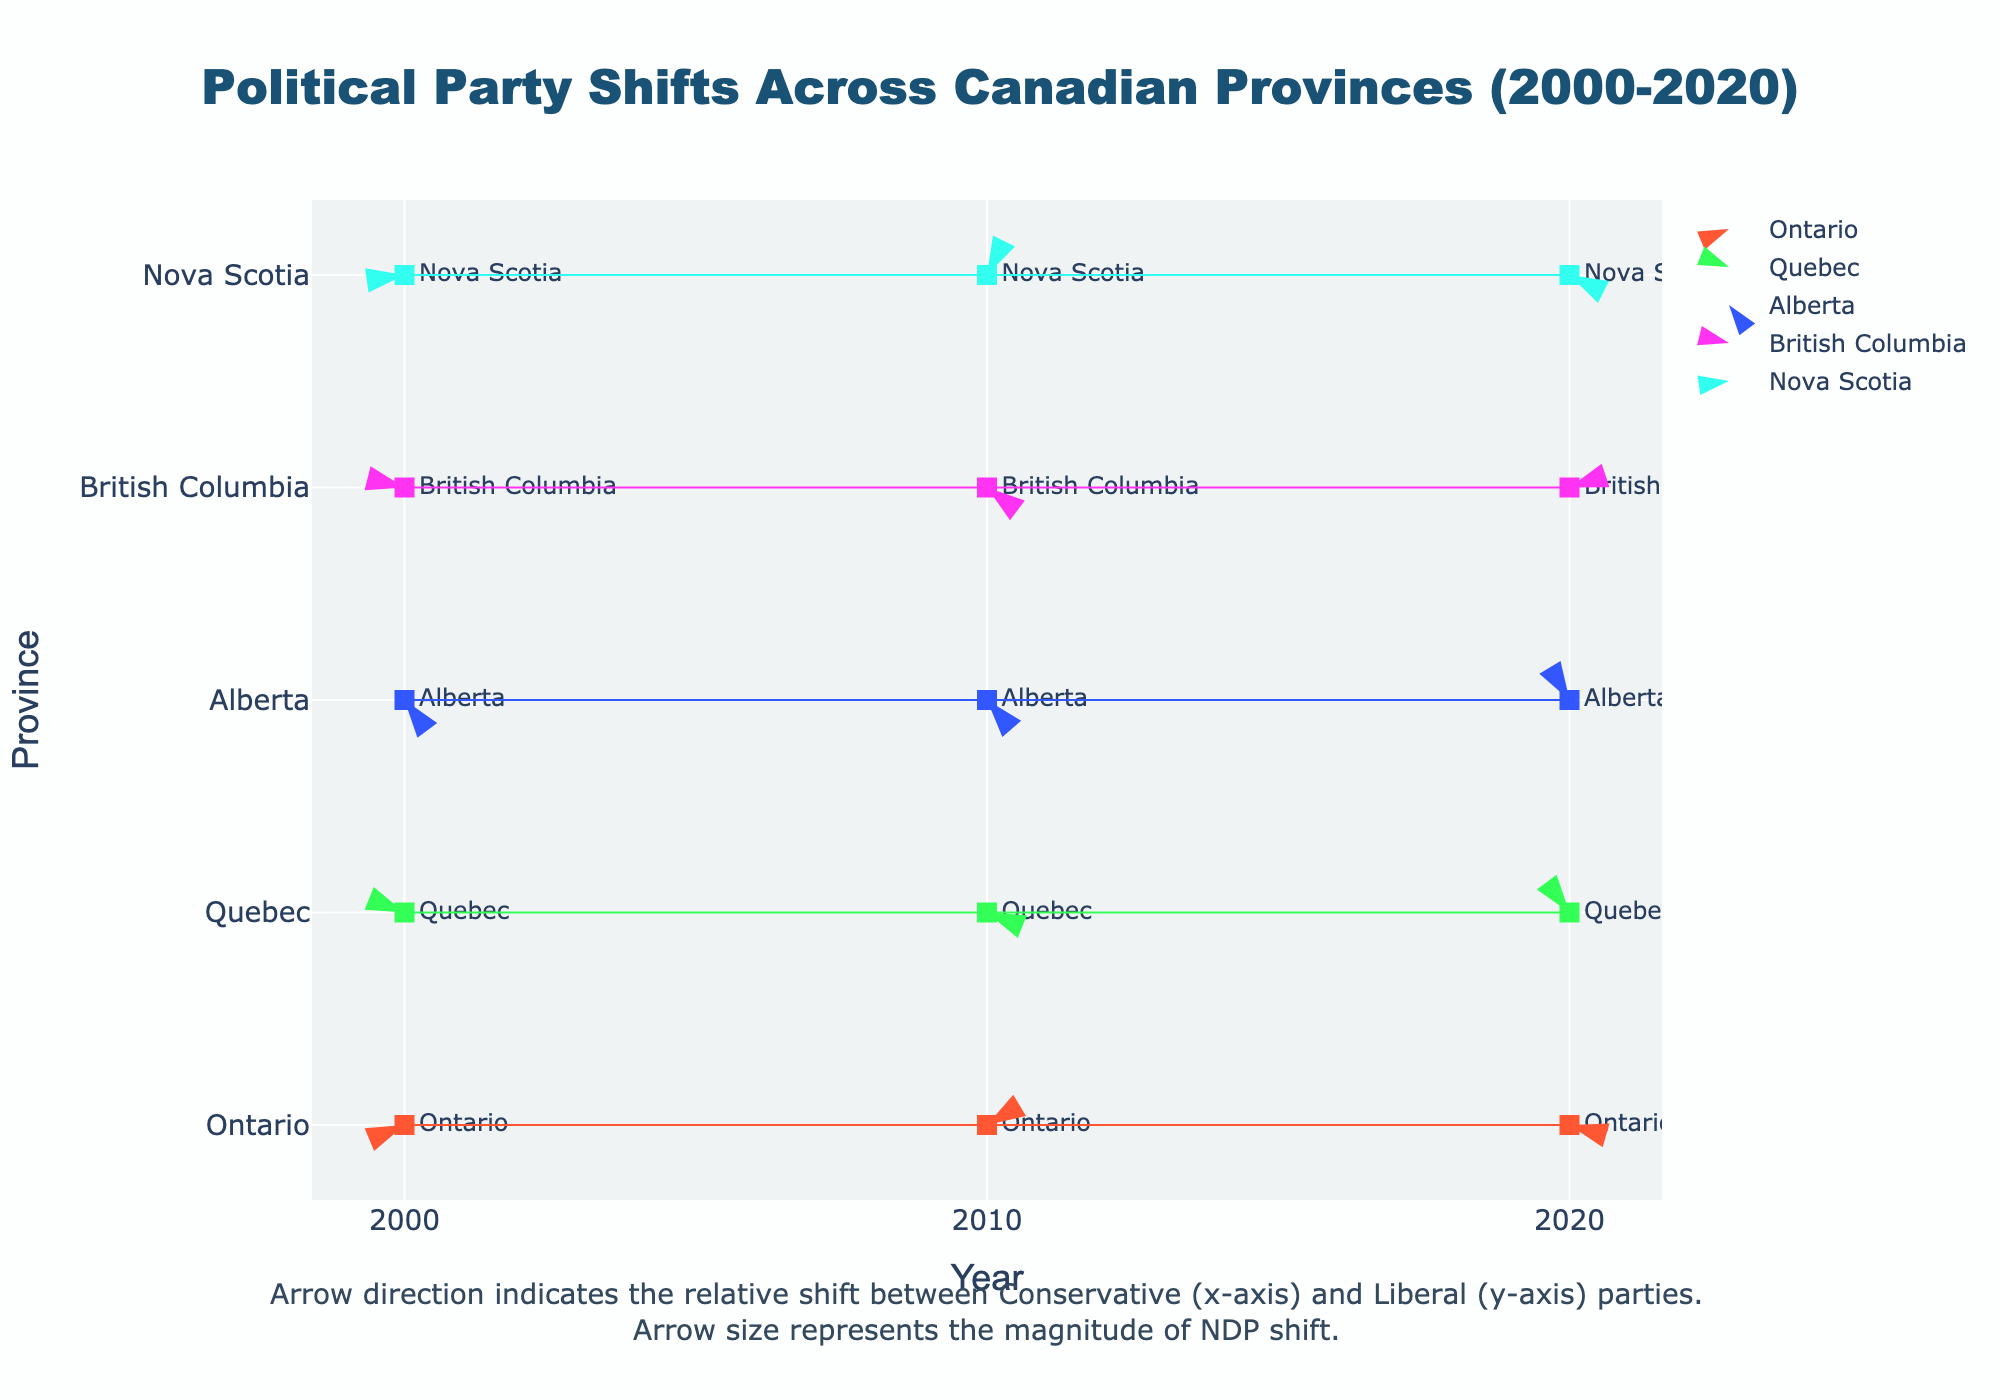What is the title of the figure? The title of the figure is located at the top and it reads, "Political Party Shifts Across Canadian Provinces (2000-2020)."
Answer: Political Party Shifts Across Canadian Provinces (2000-2020) Which province shows the largest conservative shift in 2000? The quiver plot indicates direction and magnitude of shifts; to determine the largest Conservative shift, look for the province with the longest arrow pointing towards the Conservative direction. In 2000, Alberta shows the largest positive conservative shift.
Answer: Alberta How did the political landscape in Quebec change for the Conservative and Liberal parties between 2000 and 2020? Look at the arrows representing Quebec in 2000 and 2020. In 2000, the arrow for Quebec shows a negative shift for Conservatives and a large positive shift for Liberals. In 2020, the arrow shows a negative shift for Conservatives and a positive shift for Liberals but less significantly than in 2000.
Answer: Conservative shift decreased more negatively and Liberal shift decreased Which province had a positive shift for both Conservative and Liberal parties at any point in time? Examine the arrows' directions across all provinces for any point in time. In 2010, Ontario had a small negative shift in both Conservative and Liberal parties.
Answer: None Which year shows the greatest overall shift for the province of British Columbia? Look at the arrows for British Columbia in 2000, 2010, and 2020 and compare the length and direction of the arrows. The longest arrow, representing the greatest overall magnitude of shift, occurred in 2000.
Answer: 2000 Between 2000 and 2020, which province experienced the most significant positive shift in NDP? Examine the length of the arrows in the direction that indicates NDP positive shift. Nova Scotia in 2010 shows the largest positive shift for NDP.
Answer: Nova Scotia How does the shift in Alberta's political landscape in 2020 compare to that in 2010? Look at the direction and length of the arrows for Alberta in 2010 and 2020. In 2010, the arrow points positively for Conservative but negatively for Liberal and NDP. In 2020, the shift is negative for Conservative, positive for Liberal, and slightly positive for NDP. Alberta shows a significant change from a strong Conservative shift towards more balanced shifts with slight Liberal and NDP positives in 2020.
Answer: More balanced shifts in 2020 Which provinces show a negative shift in both Liberal and Conservative parties while NDP shows a positive shift? Look at the direction of the arrows for each province. In 2010, Ontario shows negative shifts for both Conservative and Liberal while having a positive shift for NDP.
Answer: Ontario 